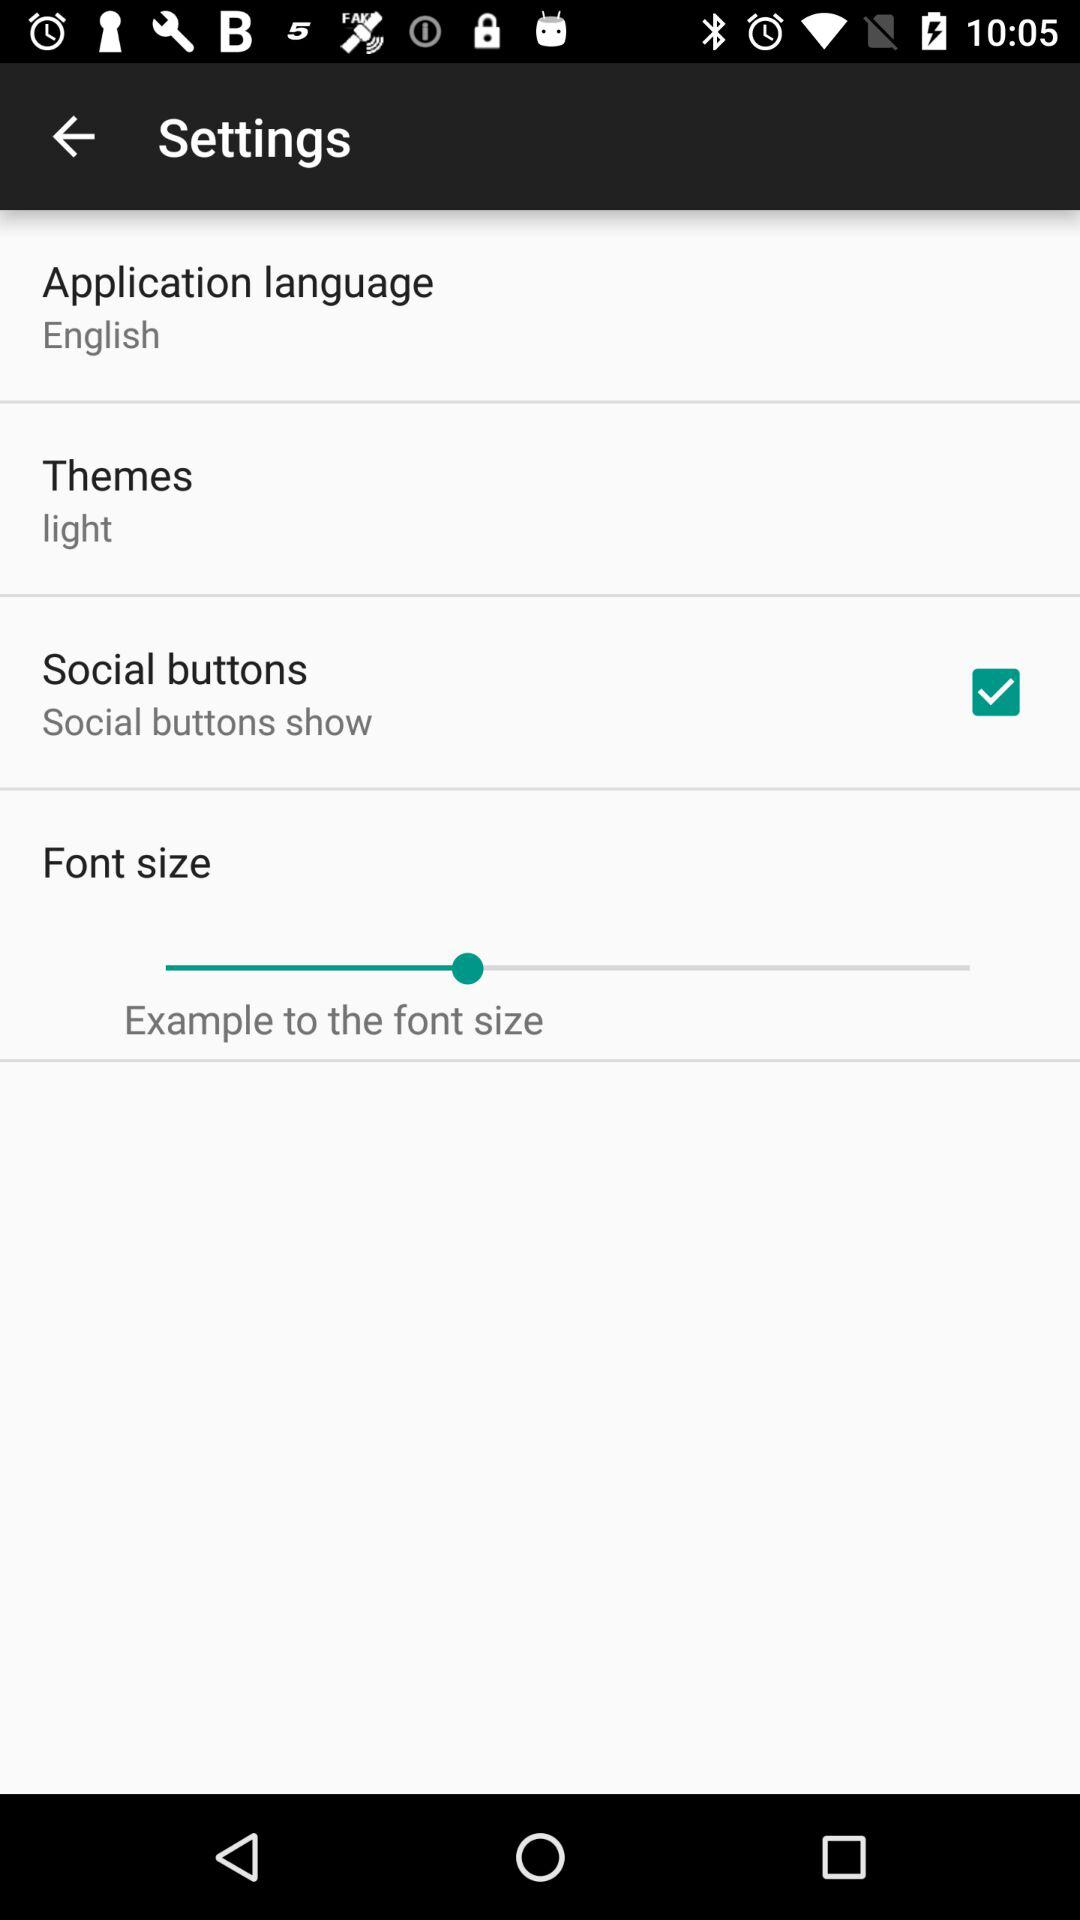What is the selected language? The selected language is English. 